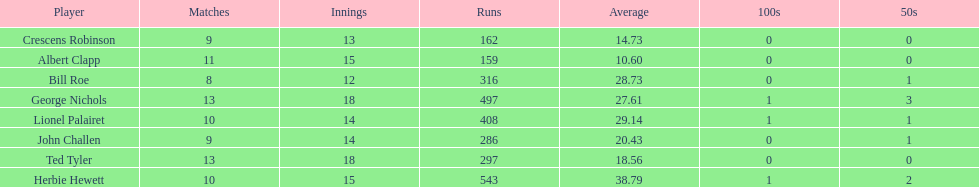Name a player whose average was above 25. Herbie Hewett. 